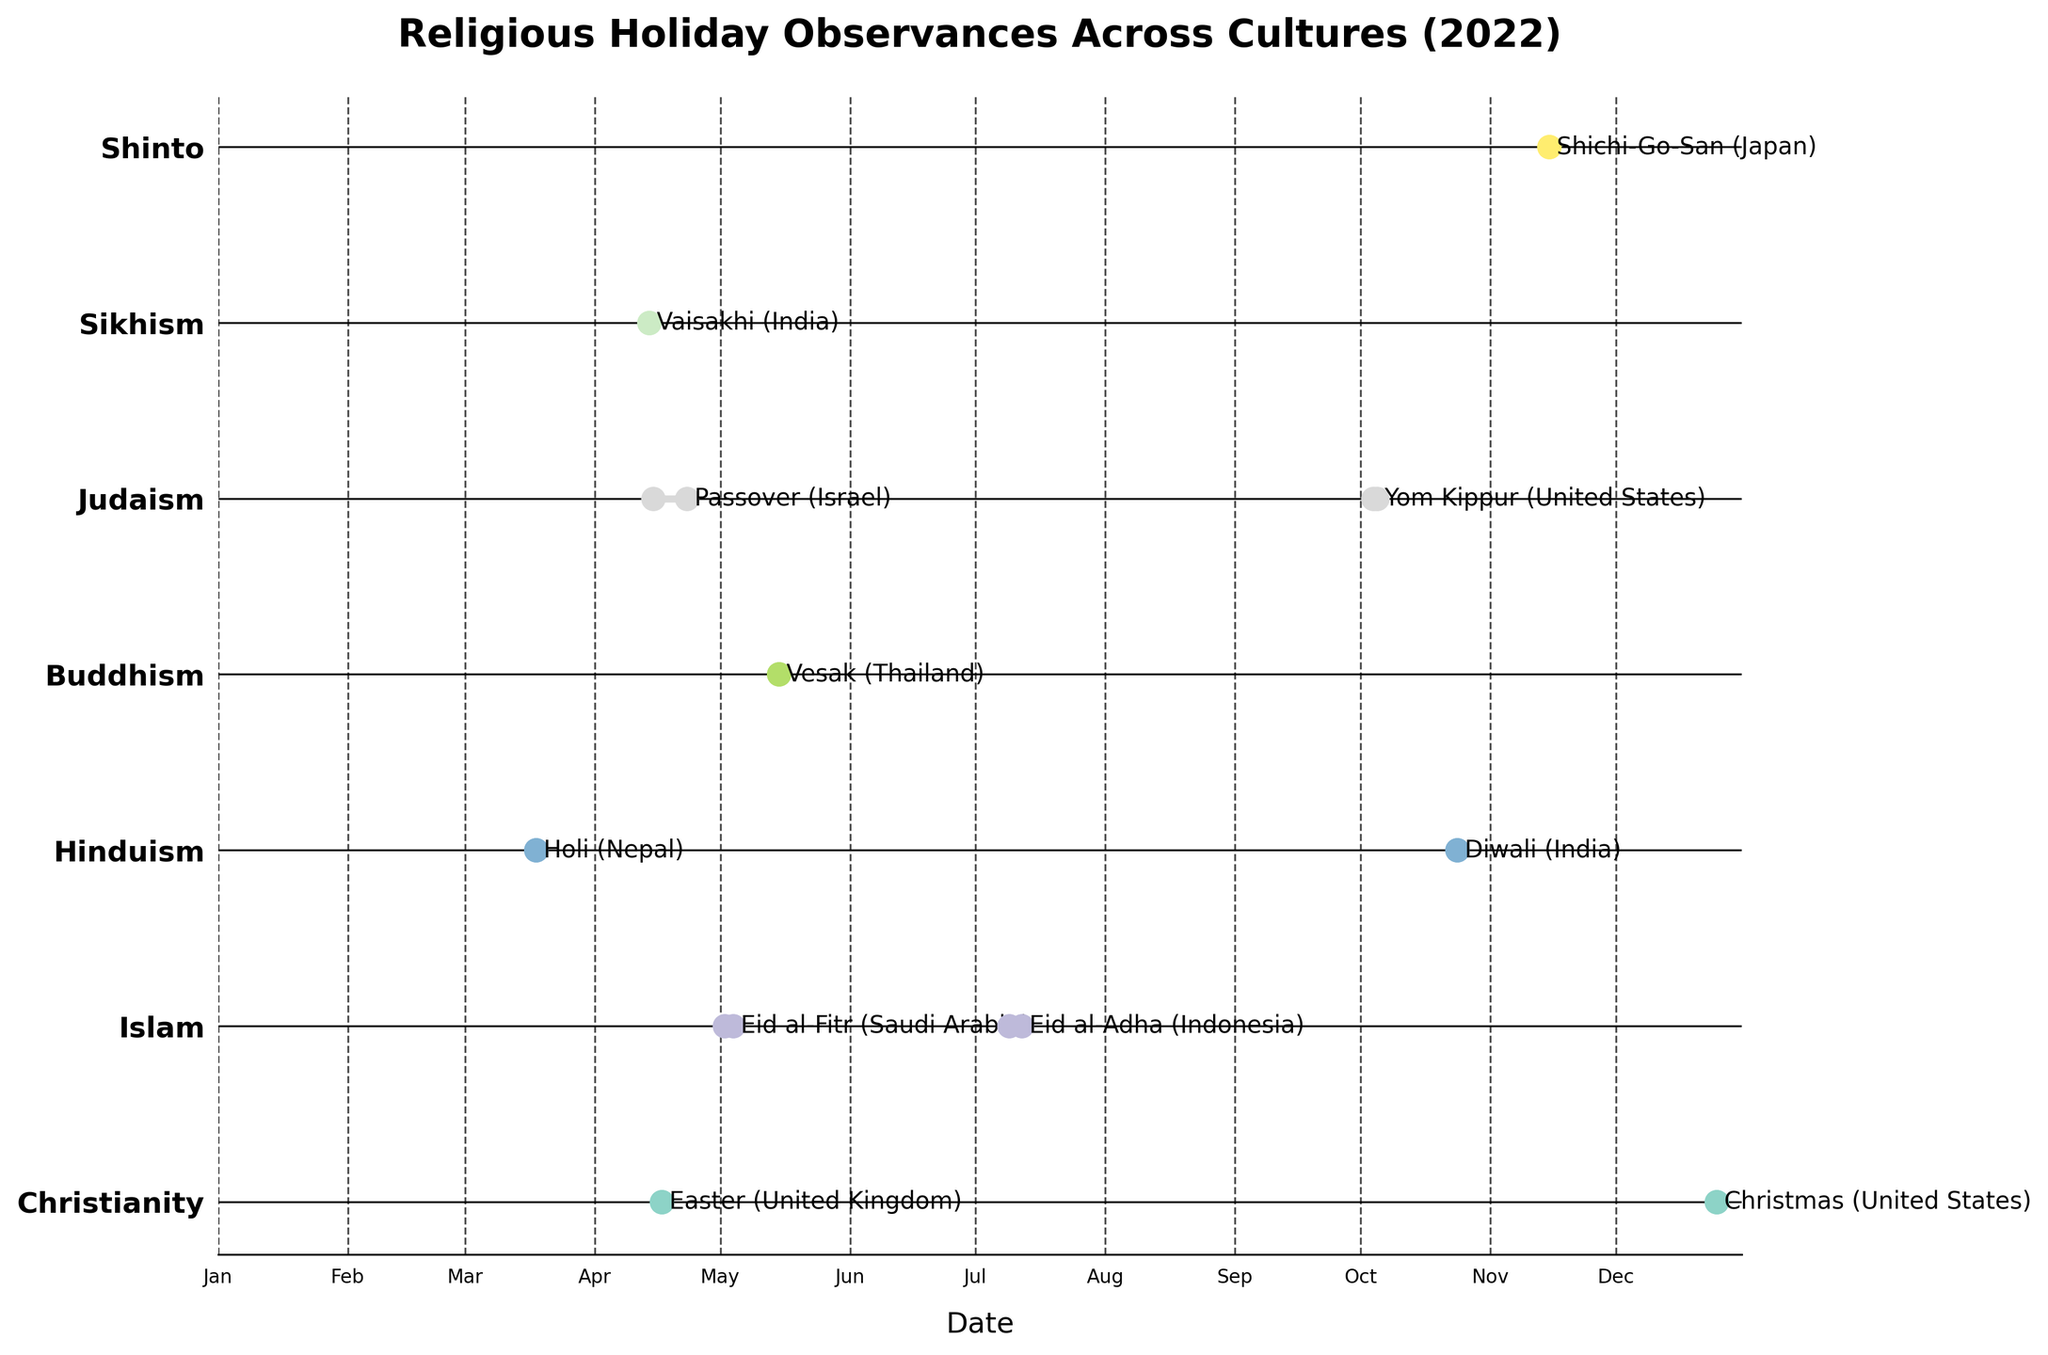What is the title of the plot? The title of the plot is typically displayed prominently at the top of the figure. In this case, it reads "Religious Holiday Observances Across Cultures (2022)".
Answer: Religious Holiday Observances Across Cultures (2022) Which religion has the holiday with the longest duration observed in 2022? To determine the holiday with the longest duration, look for the range (difference between start and end dates) of each line on the plot. Judaism's Passover, observed in Israel, spans from April 15 to April 23, making it the longest with 9 days.
Answer: Judaism (Passover) How many holidays in total are represented on the plot? By counting the number of distinct lines or range markers that indicate different holidays, you can find this total. There are 11 holidays represented in the plot.
Answer: 11 Which holidays does the plot show as being celebrated for more than one day? Identify holidays where the range marker covers more than one date. The holidays celebrated for more than one day are Eid al-Fitr (Saudi Arabia), Eid al-Adha (Indonesia), Passover (Israel), and Yom Kippur (United States).
Answer: Eid al-Fitr, Eid al-Adha, Passover, Yom Kippur Which countries are shown as observing Christian holidays? By checking the labels attached to holidays under Christianity in the plot, you can see the countries listed. For Christianity, the countries are the United States (Christmas) and the United Kingdom (Easter).
Answer: United States, United Kingdom How does the duration of Jewish holidays compare to Hindu holidays? Compare the longest duration of a holiday in each religion. Jewish holidays in the plot include Passover (9 days) and Yom Kippur (2 days). Hindu holidays include Diwali and Holi, both observed for 1 day. Jewish holidays have longer durations.
Answer: Jewish holidays last longer What is the range of dates during which all observed holidays fall? By examining the start date of the earliest holiday and the end date of the latest holiday, you can identify the range. The earliest holiday is Vaisakhi (April 14) and the latest is Shichi-Go-San (November 15).
Answer: April 14 to November 15 Which religion has the most holidays represented on the plot? Count the number of holidays per religion. Judaism and Islam each have two holidays: Islam (Eid al-Fitr, Eid al-Adha), Judaism (Passover, Yom Kippur). They have the highest number of holidays depicted.
Answer: Judaism and Islam (2 holidays each) 